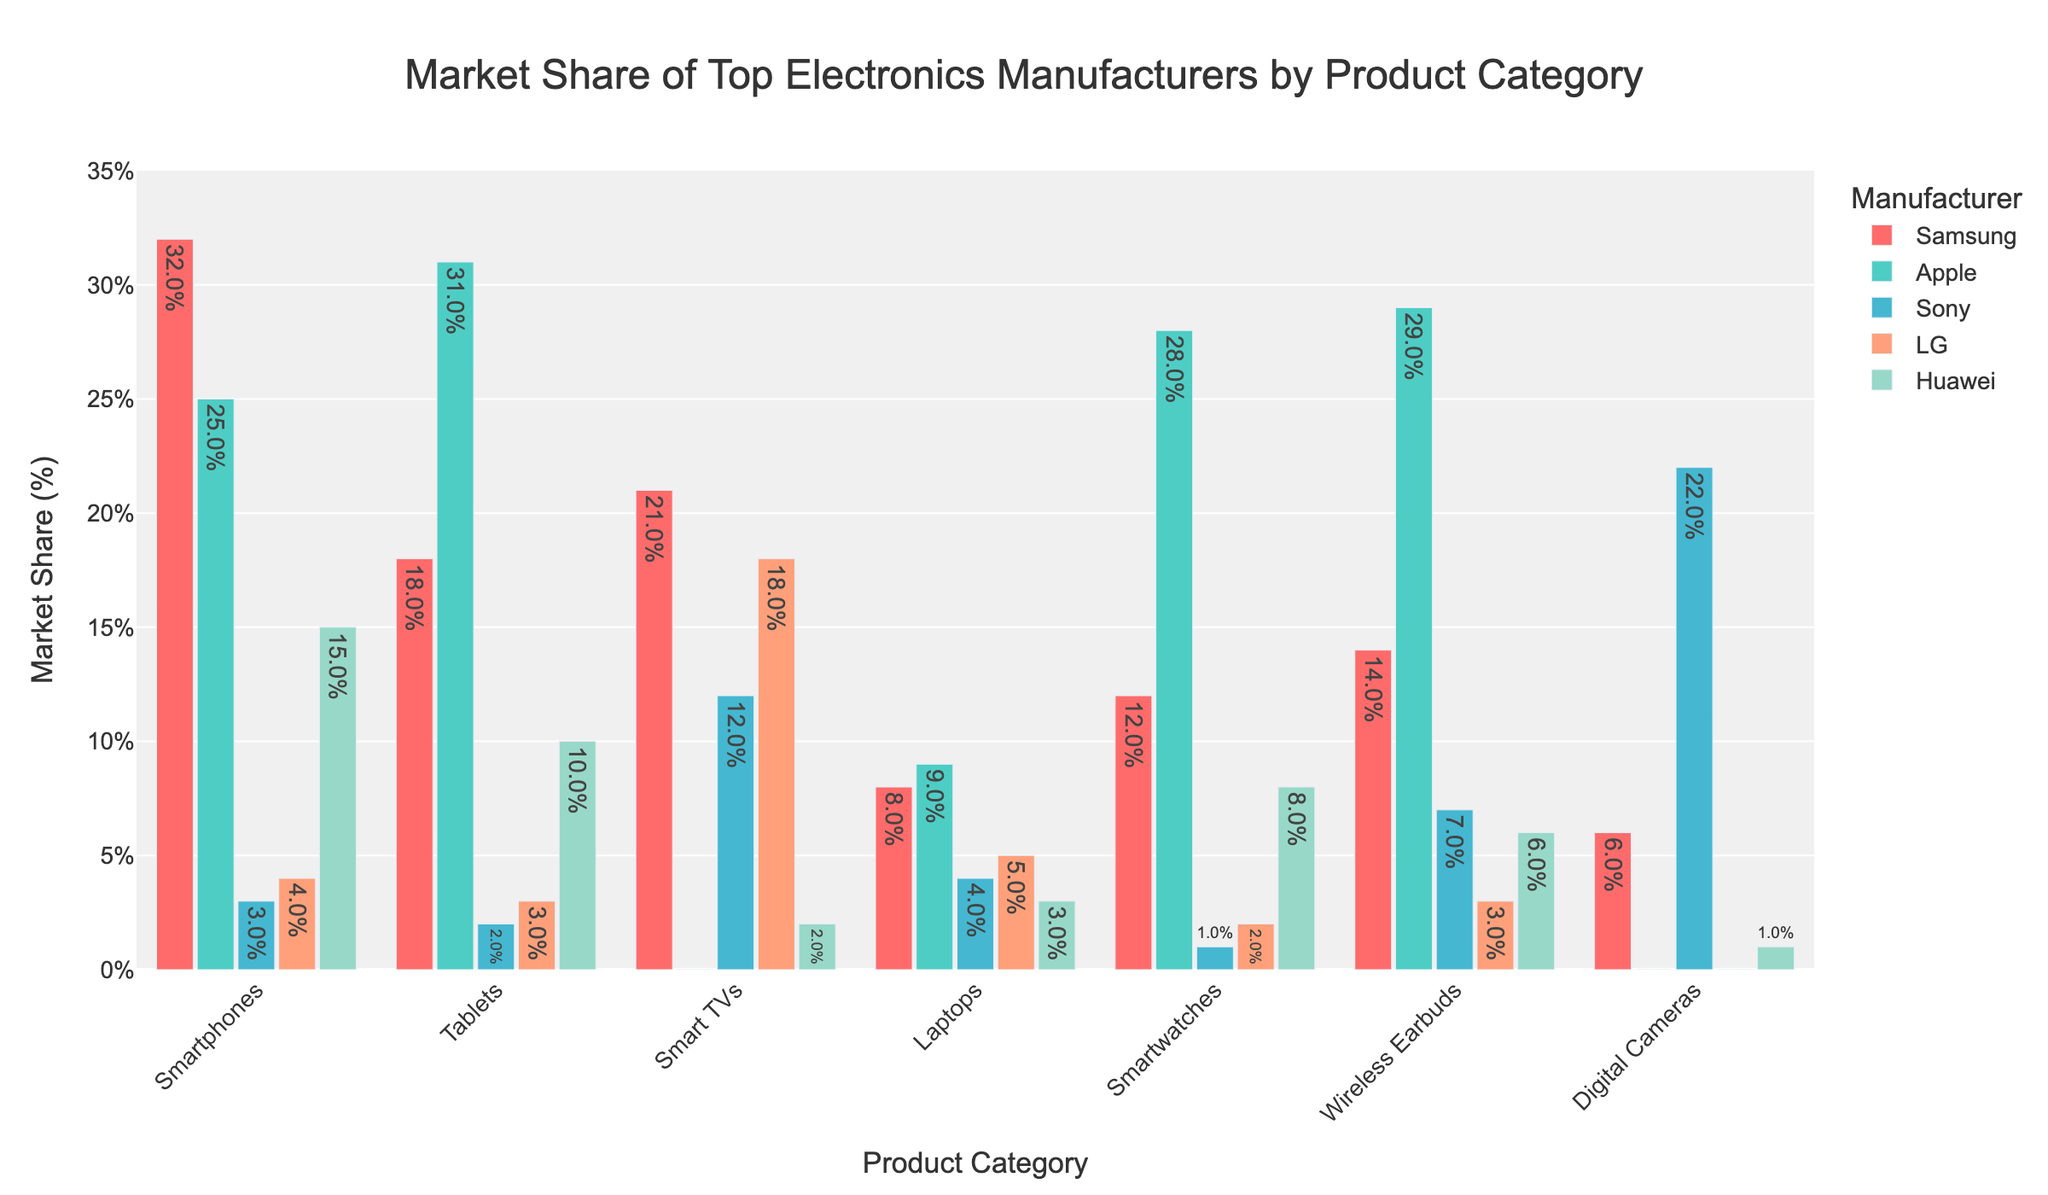What category does Samsung dominate the most? By looking at the highest bar for Samsung across all product categories, it is clear that Samsung's market share is highest in the Smartphones category at 32%.
Answer: Smartphones Which manufacturer has the highest market share in Tablets? Observing the height of the bars in the Tablets category, Apple has the tallest bar with a market share of 31%.
Answer: Apple How does LG’s market share in Smart TVs compare to Sony's? LG's bar in the Smart TVs category is higher than Sony's. Specifically, LG has an 18% market share while Sony has a 12% market share.
Answer: LG What's the combined market share of Samsung and Huawei in Smartphones? Adding the market shares of Samsung (32%) and Huawei (15%) in the Smartphones category results in a combined market share of 47%.
Answer: 47% Which category has the smallest market share for Sony? By examining the heights of Sony's bars across all categories, Sony's smallest market share is in Tablets, where it holds a 2% share.
Answer: Tablets In which categories does Apple not appear? By checking the bars for Apple, it is clear that Apple has no market share in Smart TVs and Digital Cameras as the bars for these categories are absent.
Answer: Smart TVs and Digital Cameras Is Huawei's market share in Wireless Earbuds greater or less than its market share in Tablets? Comparing the height of Huawei's bars for Wireless Earbuds (6%) and Tablets (10%), Huawei has a lower market share in Wireless Earbuds compared to Tablets.
Answer: Less What is the average market share of Apple in the categories where it has a presence? Apple has a market share in Smartphones (25%), Tablets (31%), Laptops (9%), Smartwatches (28%), and Wireless Earbuds (29%). The average is calculated as (25 + 31 + 9 + 28 + 29) / 5 = 24.4%.
Answer: 24.4% Which category shows Samsung having a larger market share than Apple? Samsung's market share in Smartphones (32%) is larger than Apple's 25%. Similarly, Samsung also dominates in Smart TVs with 21% where Apple is absent.
Answer: Smartphones and Smart TVs What's the difference in market share between Sony and LG in Digital Cameras? Sony's market share in Digital Cameras is 22%, while LG has 0%. The difference is 22% - 0% = 22%.
Answer: 22% 